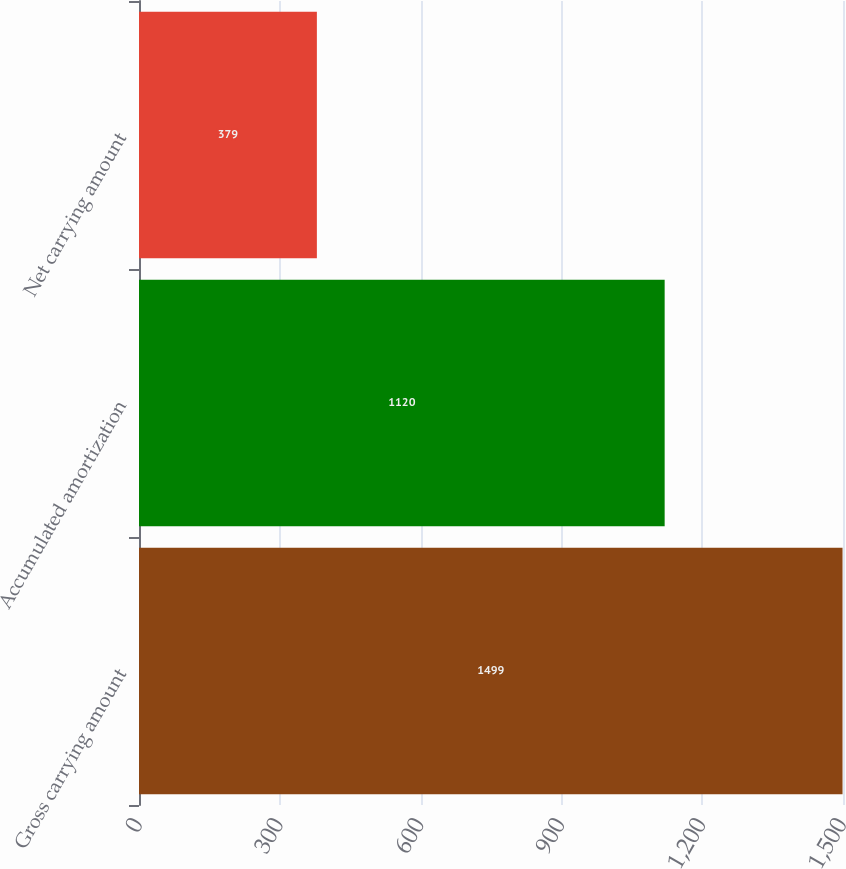<chart> <loc_0><loc_0><loc_500><loc_500><bar_chart><fcel>Gross carrying amount<fcel>Accumulated amortization<fcel>Net carrying amount<nl><fcel>1499<fcel>1120<fcel>379<nl></chart> 